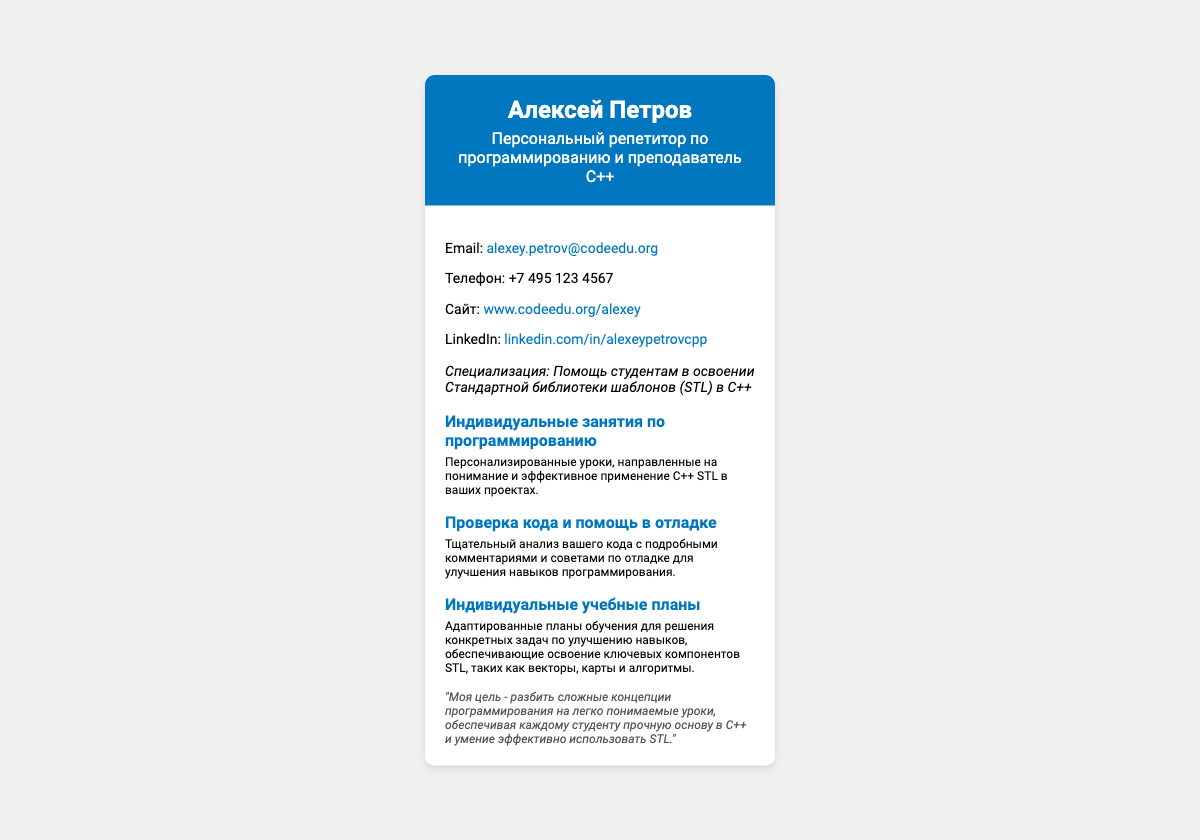Что за профессию имеет Алексей Петров? Это указано в заголовке документа, где он описан как "Персональный репетитор по программированию и преподаватель C++".
Answer: преподаватель C++ Какой адрес электронной почты у Алексея Петрова? Это информация из раздела контактной информации документа, где указана его электронная почта.
Answer: alexey.petrov@codeedu.org Какой номер телефона указан? Это информация из раздела контактной информации, где написан номер телефона Алексея Петрова.
Answer: +7 495 123 4567 Какая основная специализация Алексея Петрова? Это указано в разделе специализации, где упоминается его помощь в освоении STL в C++.
Answer: STL в C++ Какова философия Алексея Петрова? Это указано в разделе философия документа, где он делится своей целью в преподавании.
Answer: "Моя цель - разбить сложные концепции программирования на легко понимаемые уроки." Что включает в себя индивидуальный учебный план? Это указано в описании услуг, где говорится о планах, адаптированных для конкретных задач.
Answer: Адаптированные планы обучения Какие услуги предоставляет Алексей Петров? Эта информация представлена в разделе услуг, где перечислены разные типы занятий.
Answer: Индивидуальные занятия по программированию Для чего предназначены персонализированные уроки? Это объясняется в описании, где упоминается их цель.
Answer: Понимание и эффективное применение C++ STL Какой стиль шрифта используется в документе? Это можно узнать из CSS раздела стилей, примененного к документу.
Answer: Roboto 